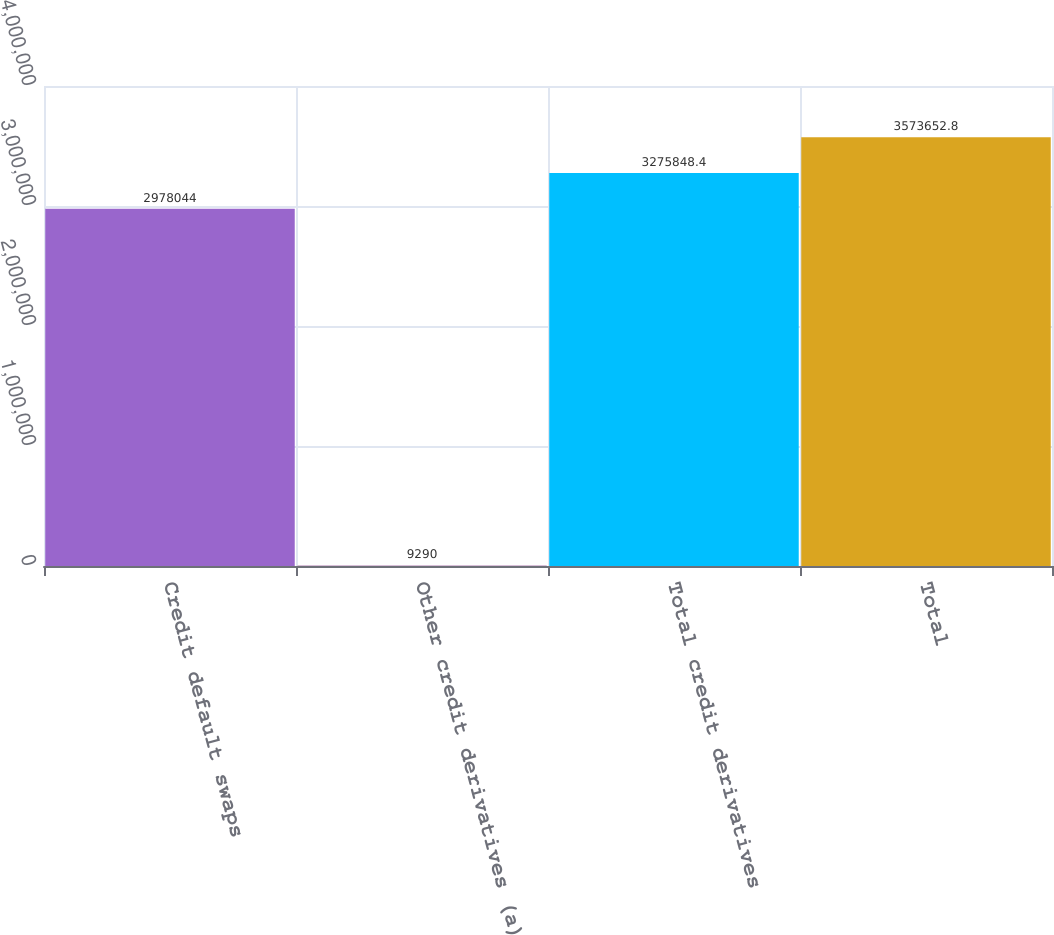Convert chart. <chart><loc_0><loc_0><loc_500><loc_500><bar_chart><fcel>Credit default swaps<fcel>Other credit derivatives (a)<fcel>Total credit derivatives<fcel>Total<nl><fcel>2.97804e+06<fcel>9290<fcel>3.27585e+06<fcel>3.57365e+06<nl></chart> 